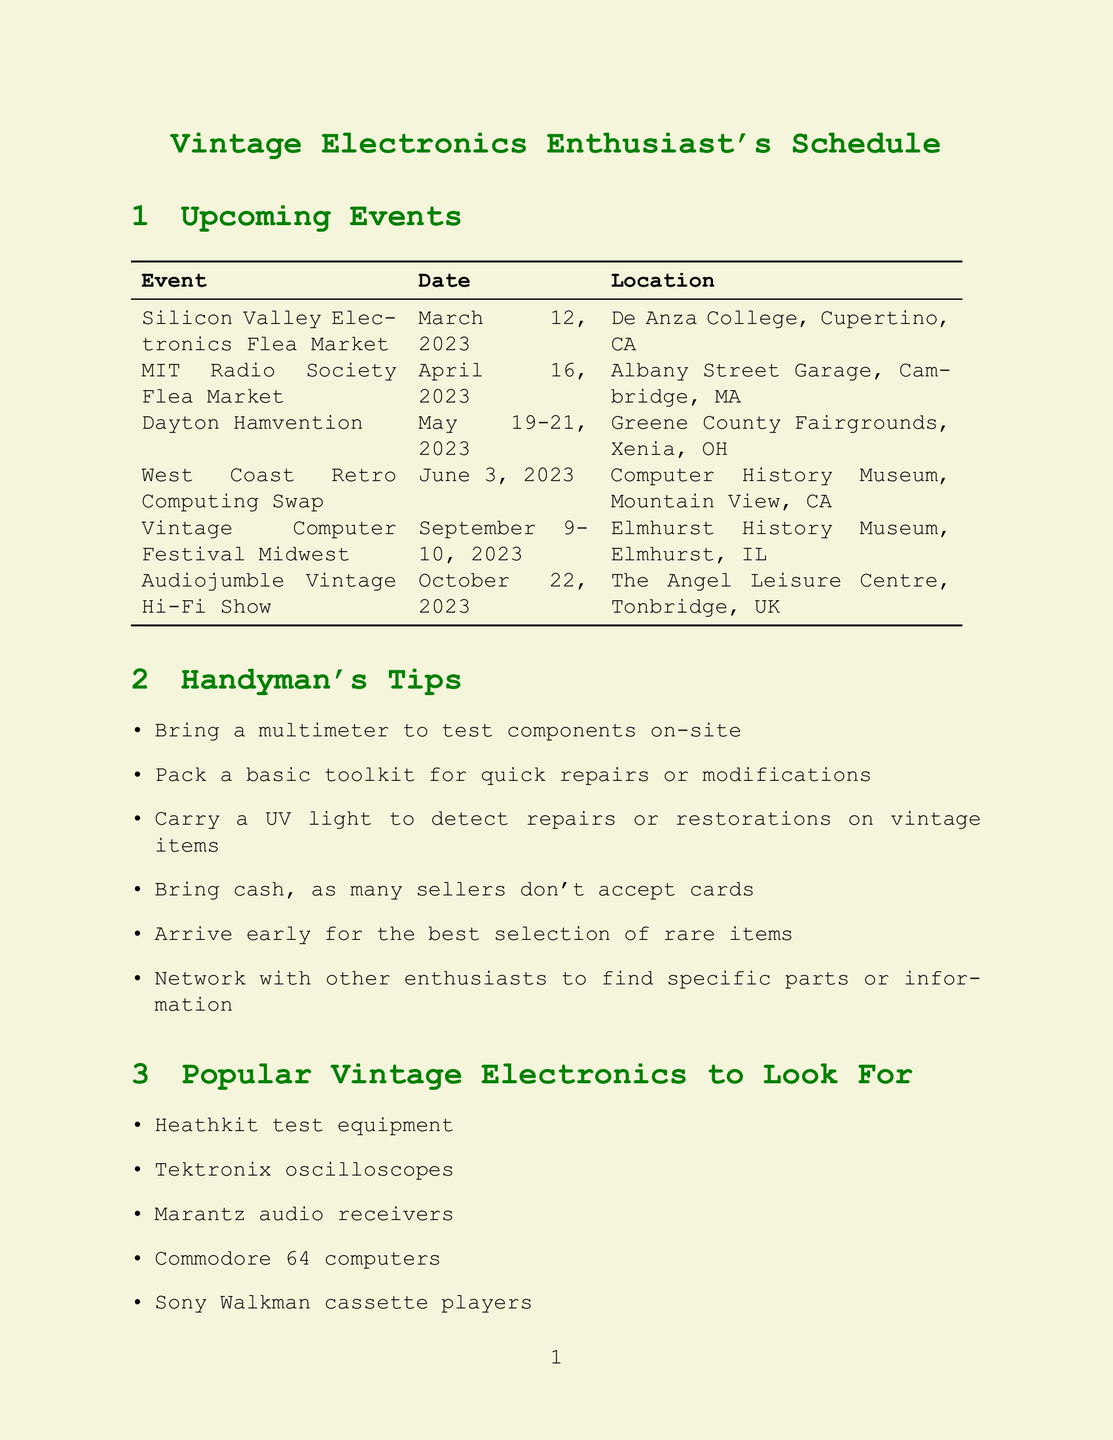What is the location of the Silicon Valley Electronics Flea Market? The location is listed in the event details of the Silicon Valley Electronics Flea Market, which is De Anza College, Cupertino, CA.
Answer: De Anza College, Cupertino, CA When is the next MIT Radio Society Flea Market? The dates for the MIT Radio Society Flea Market are specified, with the next event being on April 16, 2023.
Answer: April 16, 2023 How long does the Dayton Hamvention last? The duration is mentioned in the details of the Dayton Hamvention, which is from May 19 to May 21, 2023.
Answer: May 19-21, 2023 What time does the Audiojumble Vintage Hi-Fi Show start? The starting time is indicated in the event details of the Audiojumble Vintage Hi-Fi Show, which is 10:30 AM.
Answer: 10:30 AM How many tips are provided for handymen? The document lists various tips under the handyman's section, totaling six tips provided.
Answer: Six tips What is one of the popular vintage electronics mentioned? The document features a list of popular vintage electronics, including Heathkit test equipment.
Answer: Heathkit test equipment Which event is scheduled for October 8, 2023? The October 8, 2023 date is associated with a specific event, which is the Silicon Valley Electronics Flea Market.
Answer: Silicon Valley Electronics Flea Market What should you bring to test components on-site? The tips recommend bringing a specific tool to help with testing, which is a multimeter.
Answer: Multimeter What time does the West Coast Retro Computing Swap take place? The document provides details regarding the time of the West Coast Retro Computing Swap, which is 11:00 AM to 4:00 PM.
Answer: 11:00 AM - 4:00 PM 